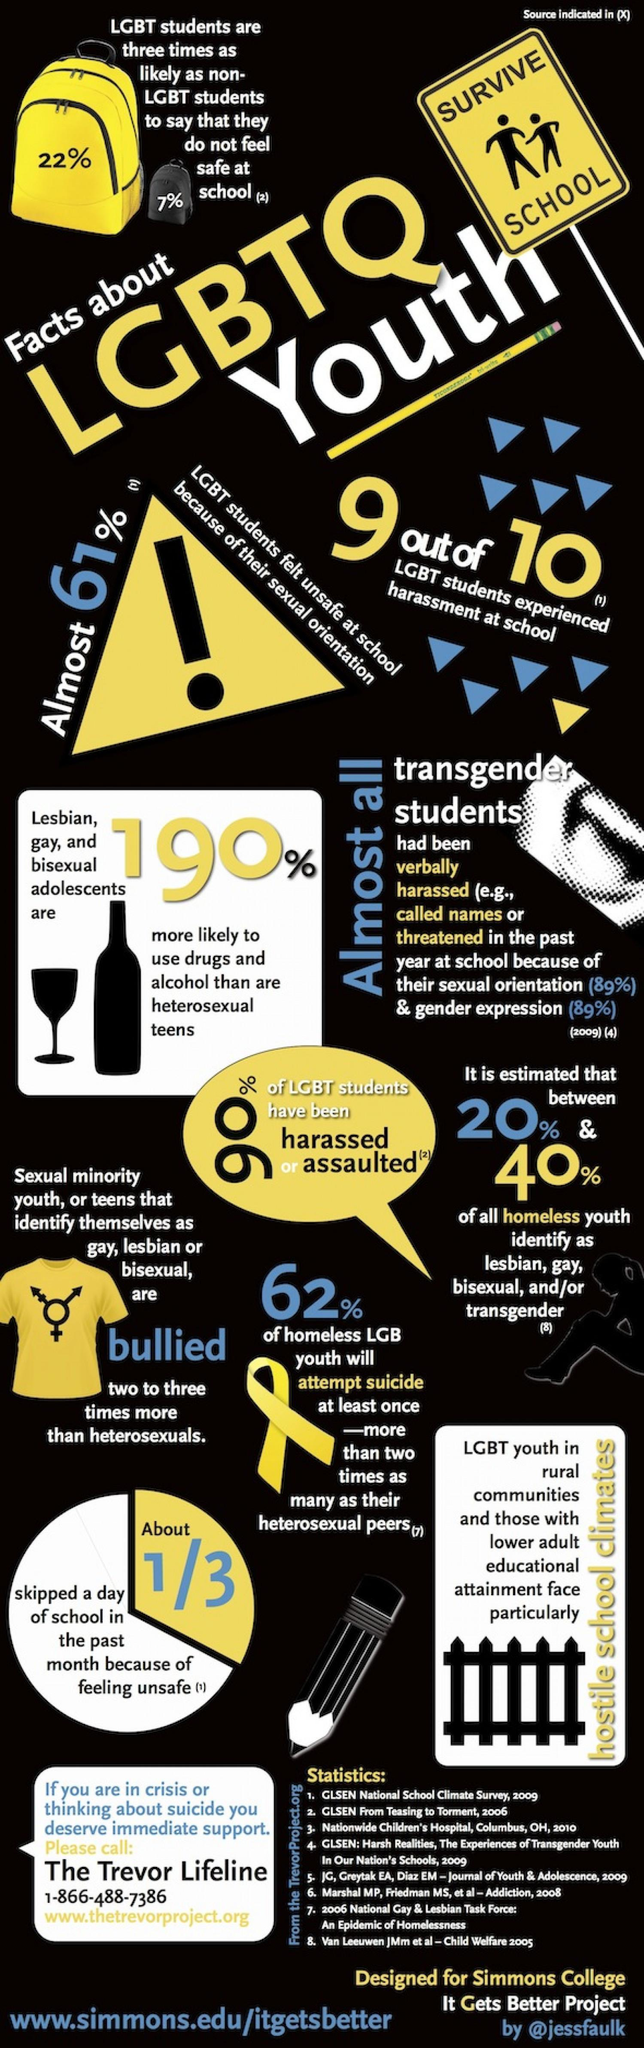What percentage of LGBT students do not feel safe at school?
Answer the question with a short phrase. 22% What percentage of homeless LGB youth attempted suicide? 62% What percentage of LGBT students have been harassed or assaulted in schools? 90% What percentage of non-LGBT students do not feel safe at school? 7% What percentage of LGBT students felt unsafe at school because of their sexual orientation? 61% 